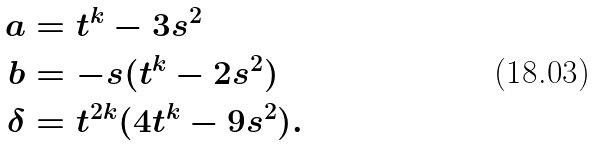<formula> <loc_0><loc_0><loc_500><loc_500>a & = t ^ { k } - 3 s ^ { 2 } \\ b & = - s ( t ^ { k } - 2 s ^ { 2 } ) \\ \delta & = t ^ { 2 k } ( 4 t ^ { k } - 9 s ^ { 2 } ) .</formula> 